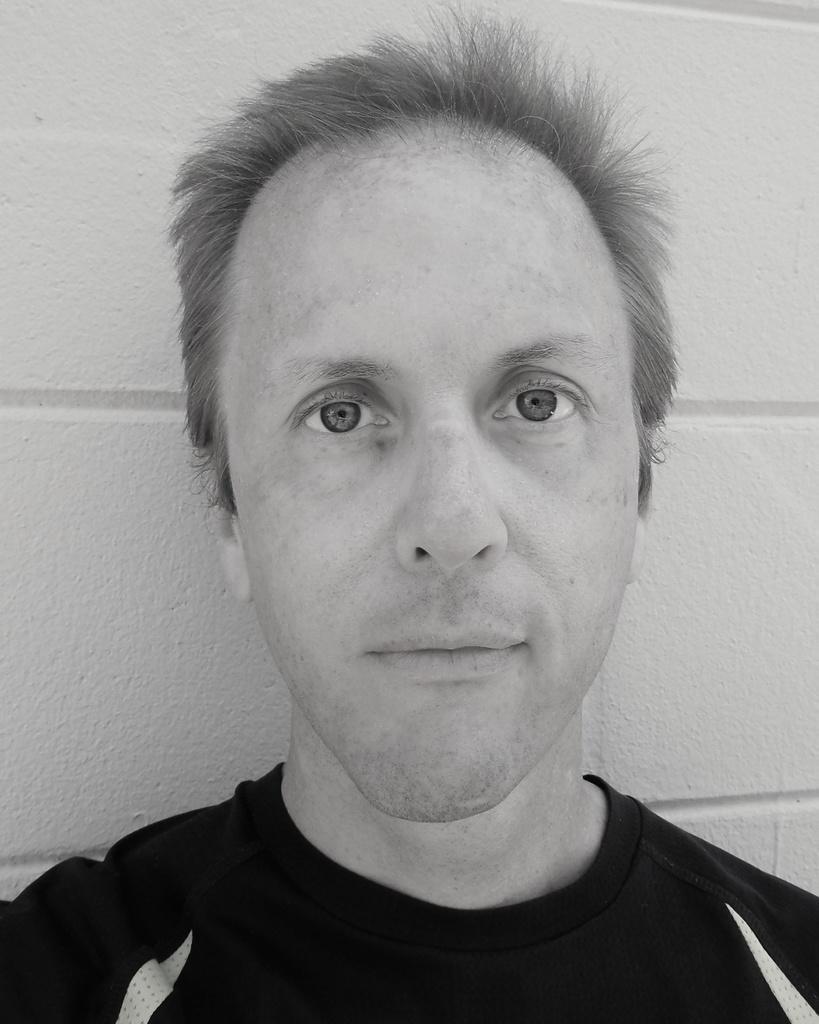How would you summarize this image in a sentence or two? In this picture we can see a man, and it is a black and white photography. 